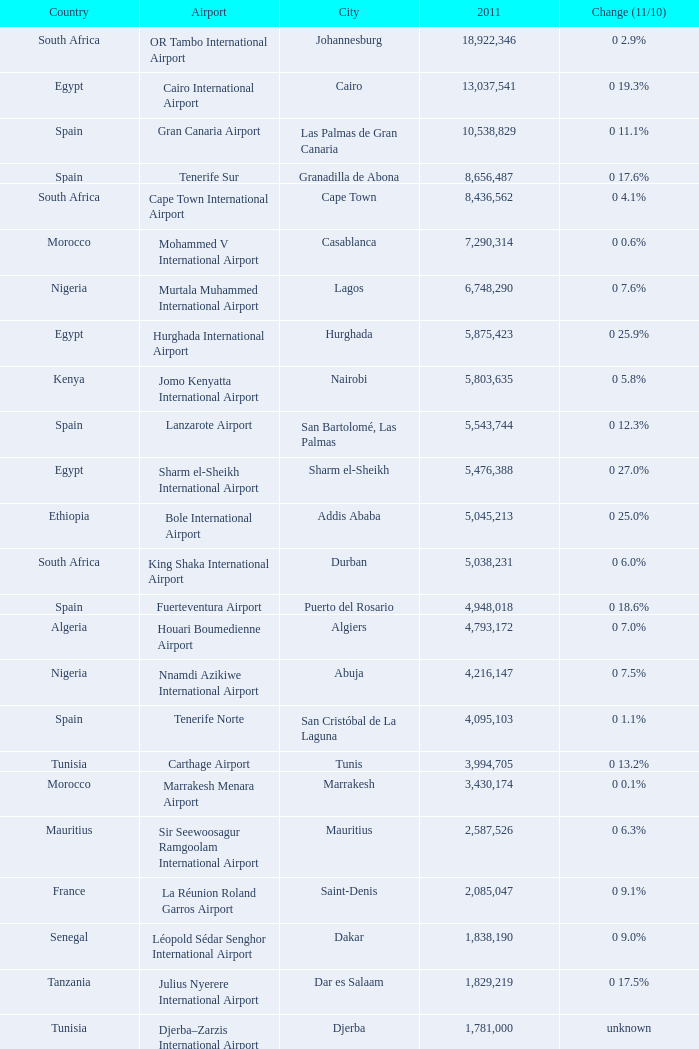Which place had bole international airport in the year 2011? 5045213.0. 